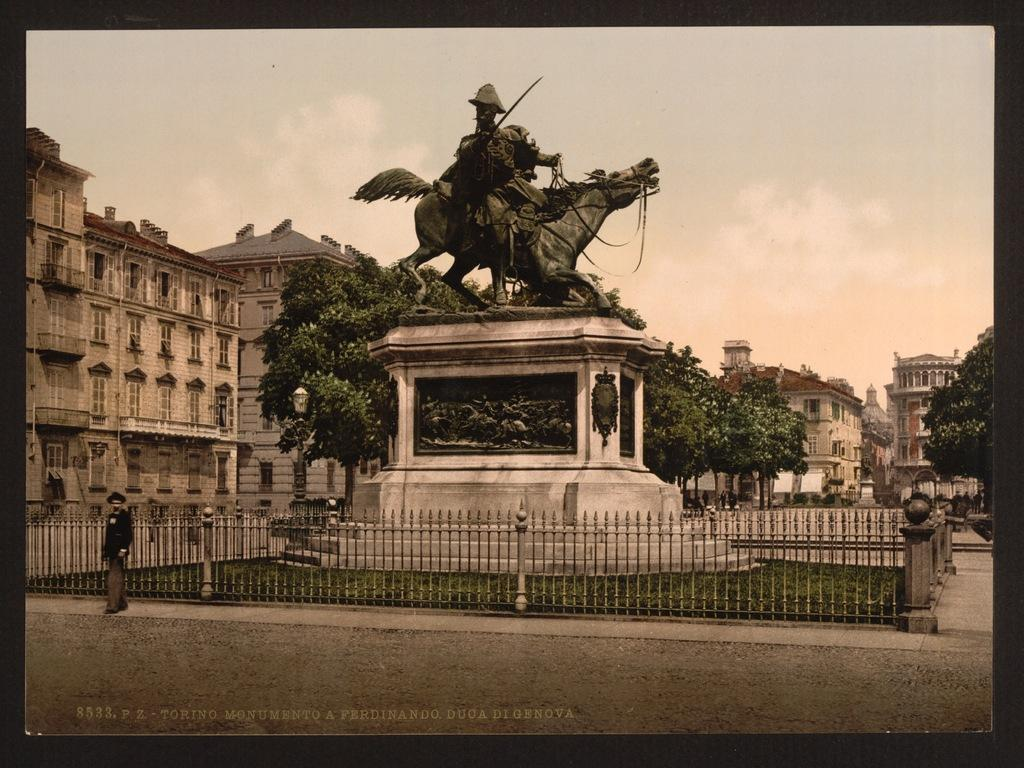What is the man doing in the image? The man is standing on the ground in the image. What other object or structure can be seen in the image? There is a statue in the image. What type of natural elements are present in the image? There are trees in the image. What type of man-made structures are visible in the image? There are buildings with windows in the image. What can be seen in the background of the image? The sky with clouds is visible in the background of the image. What type of thread is being used to hold the clouds together in the image? There is no thread visible in the image; the clouds are a natural part of the sky. 